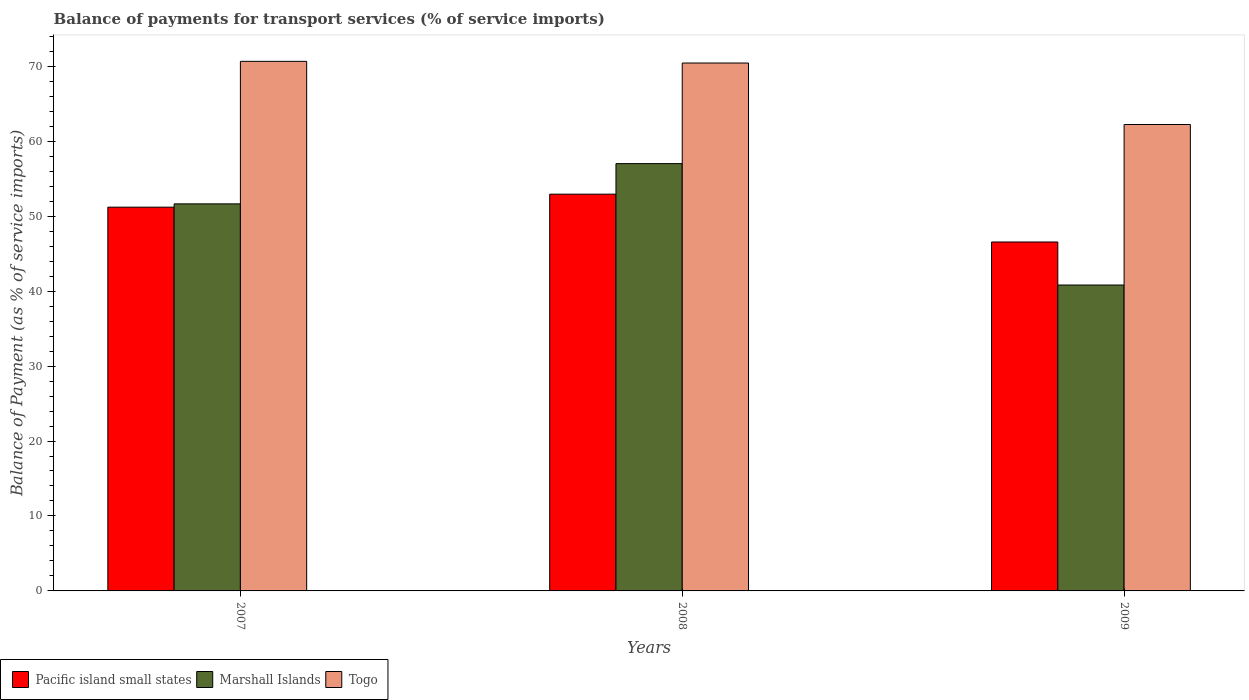How many different coloured bars are there?
Your answer should be compact. 3. Are the number of bars per tick equal to the number of legend labels?
Your answer should be compact. Yes. How many bars are there on the 3rd tick from the right?
Make the answer very short. 3. In how many cases, is the number of bars for a given year not equal to the number of legend labels?
Your response must be concise. 0. What is the balance of payments for transport services in Togo in 2008?
Provide a short and direct response. 70.43. Across all years, what is the maximum balance of payments for transport services in Togo?
Your answer should be very brief. 70.65. Across all years, what is the minimum balance of payments for transport services in Togo?
Make the answer very short. 62.23. In which year was the balance of payments for transport services in Marshall Islands maximum?
Provide a short and direct response. 2008. What is the total balance of payments for transport services in Pacific island small states in the graph?
Make the answer very short. 150.69. What is the difference between the balance of payments for transport services in Pacific island small states in 2008 and that in 2009?
Your answer should be compact. 6.38. What is the difference between the balance of payments for transport services in Pacific island small states in 2007 and the balance of payments for transport services in Togo in 2009?
Provide a succinct answer. -11.03. What is the average balance of payments for transport services in Togo per year?
Your answer should be compact. 67.77. In the year 2009, what is the difference between the balance of payments for transport services in Togo and balance of payments for transport services in Pacific island small states?
Your response must be concise. 15.68. In how many years, is the balance of payments for transport services in Marshall Islands greater than 8 %?
Offer a terse response. 3. What is the ratio of the balance of payments for transport services in Marshall Islands in 2007 to that in 2009?
Your answer should be very brief. 1.27. Is the balance of payments for transport services in Togo in 2007 less than that in 2009?
Offer a very short reply. No. Is the difference between the balance of payments for transport services in Togo in 2008 and 2009 greater than the difference between the balance of payments for transport services in Pacific island small states in 2008 and 2009?
Provide a succinct answer. Yes. What is the difference between the highest and the second highest balance of payments for transport services in Marshall Islands?
Your response must be concise. 5.37. What is the difference between the highest and the lowest balance of payments for transport services in Pacific island small states?
Ensure brevity in your answer.  6.38. In how many years, is the balance of payments for transport services in Marshall Islands greater than the average balance of payments for transport services in Marshall Islands taken over all years?
Offer a terse response. 2. Is the sum of the balance of payments for transport services in Pacific island small states in 2008 and 2009 greater than the maximum balance of payments for transport services in Marshall Islands across all years?
Give a very brief answer. Yes. What does the 3rd bar from the left in 2009 represents?
Offer a terse response. Togo. What does the 3rd bar from the right in 2007 represents?
Your answer should be very brief. Pacific island small states. How many years are there in the graph?
Keep it short and to the point. 3. What is the difference between two consecutive major ticks on the Y-axis?
Ensure brevity in your answer.  10. Are the values on the major ticks of Y-axis written in scientific E-notation?
Your response must be concise. No. Does the graph contain grids?
Your response must be concise. No. Where does the legend appear in the graph?
Your answer should be very brief. Bottom left. How many legend labels are there?
Keep it short and to the point. 3. What is the title of the graph?
Offer a terse response. Balance of payments for transport services (% of service imports). What is the label or title of the X-axis?
Offer a very short reply. Years. What is the label or title of the Y-axis?
Offer a very short reply. Balance of Payment (as % of service imports). What is the Balance of Payment (as % of service imports) in Pacific island small states in 2007?
Your answer should be compact. 51.2. What is the Balance of Payment (as % of service imports) in Marshall Islands in 2007?
Offer a very short reply. 51.64. What is the Balance of Payment (as % of service imports) of Togo in 2007?
Ensure brevity in your answer.  70.65. What is the Balance of Payment (as % of service imports) in Pacific island small states in 2008?
Your answer should be very brief. 52.94. What is the Balance of Payment (as % of service imports) in Marshall Islands in 2008?
Provide a short and direct response. 57.01. What is the Balance of Payment (as % of service imports) of Togo in 2008?
Give a very brief answer. 70.43. What is the Balance of Payment (as % of service imports) in Pacific island small states in 2009?
Offer a terse response. 46.55. What is the Balance of Payment (as % of service imports) of Marshall Islands in 2009?
Offer a terse response. 40.81. What is the Balance of Payment (as % of service imports) of Togo in 2009?
Provide a short and direct response. 62.23. Across all years, what is the maximum Balance of Payment (as % of service imports) of Pacific island small states?
Your answer should be compact. 52.94. Across all years, what is the maximum Balance of Payment (as % of service imports) of Marshall Islands?
Give a very brief answer. 57.01. Across all years, what is the maximum Balance of Payment (as % of service imports) of Togo?
Make the answer very short. 70.65. Across all years, what is the minimum Balance of Payment (as % of service imports) in Pacific island small states?
Your response must be concise. 46.55. Across all years, what is the minimum Balance of Payment (as % of service imports) of Marshall Islands?
Ensure brevity in your answer.  40.81. Across all years, what is the minimum Balance of Payment (as % of service imports) of Togo?
Make the answer very short. 62.23. What is the total Balance of Payment (as % of service imports) in Pacific island small states in the graph?
Your response must be concise. 150.69. What is the total Balance of Payment (as % of service imports) of Marshall Islands in the graph?
Keep it short and to the point. 149.46. What is the total Balance of Payment (as % of service imports) of Togo in the graph?
Offer a terse response. 203.31. What is the difference between the Balance of Payment (as % of service imports) of Pacific island small states in 2007 and that in 2008?
Provide a short and direct response. -1.73. What is the difference between the Balance of Payment (as % of service imports) in Marshall Islands in 2007 and that in 2008?
Offer a terse response. -5.37. What is the difference between the Balance of Payment (as % of service imports) of Togo in 2007 and that in 2008?
Give a very brief answer. 0.22. What is the difference between the Balance of Payment (as % of service imports) of Pacific island small states in 2007 and that in 2009?
Provide a short and direct response. 4.65. What is the difference between the Balance of Payment (as % of service imports) in Marshall Islands in 2007 and that in 2009?
Your answer should be very brief. 10.83. What is the difference between the Balance of Payment (as % of service imports) in Togo in 2007 and that in 2009?
Provide a short and direct response. 8.42. What is the difference between the Balance of Payment (as % of service imports) of Pacific island small states in 2008 and that in 2009?
Provide a short and direct response. 6.38. What is the difference between the Balance of Payment (as % of service imports) in Marshall Islands in 2008 and that in 2009?
Provide a succinct answer. 16.2. What is the difference between the Balance of Payment (as % of service imports) of Togo in 2008 and that in 2009?
Make the answer very short. 8.2. What is the difference between the Balance of Payment (as % of service imports) of Pacific island small states in 2007 and the Balance of Payment (as % of service imports) of Marshall Islands in 2008?
Provide a succinct answer. -5.81. What is the difference between the Balance of Payment (as % of service imports) in Pacific island small states in 2007 and the Balance of Payment (as % of service imports) in Togo in 2008?
Your response must be concise. -19.23. What is the difference between the Balance of Payment (as % of service imports) in Marshall Islands in 2007 and the Balance of Payment (as % of service imports) in Togo in 2008?
Your response must be concise. -18.79. What is the difference between the Balance of Payment (as % of service imports) in Pacific island small states in 2007 and the Balance of Payment (as % of service imports) in Marshall Islands in 2009?
Make the answer very short. 10.39. What is the difference between the Balance of Payment (as % of service imports) in Pacific island small states in 2007 and the Balance of Payment (as % of service imports) in Togo in 2009?
Your answer should be compact. -11.03. What is the difference between the Balance of Payment (as % of service imports) in Marshall Islands in 2007 and the Balance of Payment (as % of service imports) in Togo in 2009?
Your answer should be very brief. -10.59. What is the difference between the Balance of Payment (as % of service imports) in Pacific island small states in 2008 and the Balance of Payment (as % of service imports) in Marshall Islands in 2009?
Make the answer very short. 12.12. What is the difference between the Balance of Payment (as % of service imports) of Pacific island small states in 2008 and the Balance of Payment (as % of service imports) of Togo in 2009?
Your answer should be compact. -9.29. What is the difference between the Balance of Payment (as % of service imports) of Marshall Islands in 2008 and the Balance of Payment (as % of service imports) of Togo in 2009?
Provide a short and direct response. -5.22. What is the average Balance of Payment (as % of service imports) in Pacific island small states per year?
Your response must be concise. 50.23. What is the average Balance of Payment (as % of service imports) of Marshall Islands per year?
Your answer should be compact. 49.82. What is the average Balance of Payment (as % of service imports) in Togo per year?
Your answer should be very brief. 67.77. In the year 2007, what is the difference between the Balance of Payment (as % of service imports) of Pacific island small states and Balance of Payment (as % of service imports) of Marshall Islands?
Make the answer very short. -0.44. In the year 2007, what is the difference between the Balance of Payment (as % of service imports) of Pacific island small states and Balance of Payment (as % of service imports) of Togo?
Provide a short and direct response. -19.45. In the year 2007, what is the difference between the Balance of Payment (as % of service imports) of Marshall Islands and Balance of Payment (as % of service imports) of Togo?
Your answer should be compact. -19.01. In the year 2008, what is the difference between the Balance of Payment (as % of service imports) of Pacific island small states and Balance of Payment (as % of service imports) of Marshall Islands?
Offer a terse response. -4.07. In the year 2008, what is the difference between the Balance of Payment (as % of service imports) of Pacific island small states and Balance of Payment (as % of service imports) of Togo?
Provide a succinct answer. -17.5. In the year 2008, what is the difference between the Balance of Payment (as % of service imports) in Marshall Islands and Balance of Payment (as % of service imports) in Togo?
Offer a very short reply. -13.42. In the year 2009, what is the difference between the Balance of Payment (as % of service imports) in Pacific island small states and Balance of Payment (as % of service imports) in Marshall Islands?
Keep it short and to the point. 5.74. In the year 2009, what is the difference between the Balance of Payment (as % of service imports) of Pacific island small states and Balance of Payment (as % of service imports) of Togo?
Offer a very short reply. -15.68. In the year 2009, what is the difference between the Balance of Payment (as % of service imports) of Marshall Islands and Balance of Payment (as % of service imports) of Togo?
Keep it short and to the point. -21.42. What is the ratio of the Balance of Payment (as % of service imports) of Pacific island small states in 2007 to that in 2008?
Provide a succinct answer. 0.97. What is the ratio of the Balance of Payment (as % of service imports) in Marshall Islands in 2007 to that in 2008?
Ensure brevity in your answer.  0.91. What is the ratio of the Balance of Payment (as % of service imports) in Pacific island small states in 2007 to that in 2009?
Offer a very short reply. 1.1. What is the ratio of the Balance of Payment (as % of service imports) of Marshall Islands in 2007 to that in 2009?
Give a very brief answer. 1.27. What is the ratio of the Balance of Payment (as % of service imports) in Togo in 2007 to that in 2009?
Ensure brevity in your answer.  1.14. What is the ratio of the Balance of Payment (as % of service imports) in Pacific island small states in 2008 to that in 2009?
Your response must be concise. 1.14. What is the ratio of the Balance of Payment (as % of service imports) in Marshall Islands in 2008 to that in 2009?
Provide a succinct answer. 1.4. What is the ratio of the Balance of Payment (as % of service imports) in Togo in 2008 to that in 2009?
Make the answer very short. 1.13. What is the difference between the highest and the second highest Balance of Payment (as % of service imports) in Pacific island small states?
Your response must be concise. 1.73. What is the difference between the highest and the second highest Balance of Payment (as % of service imports) of Marshall Islands?
Offer a terse response. 5.37. What is the difference between the highest and the second highest Balance of Payment (as % of service imports) of Togo?
Your response must be concise. 0.22. What is the difference between the highest and the lowest Balance of Payment (as % of service imports) in Pacific island small states?
Your answer should be very brief. 6.38. What is the difference between the highest and the lowest Balance of Payment (as % of service imports) in Marshall Islands?
Give a very brief answer. 16.2. What is the difference between the highest and the lowest Balance of Payment (as % of service imports) of Togo?
Offer a very short reply. 8.42. 